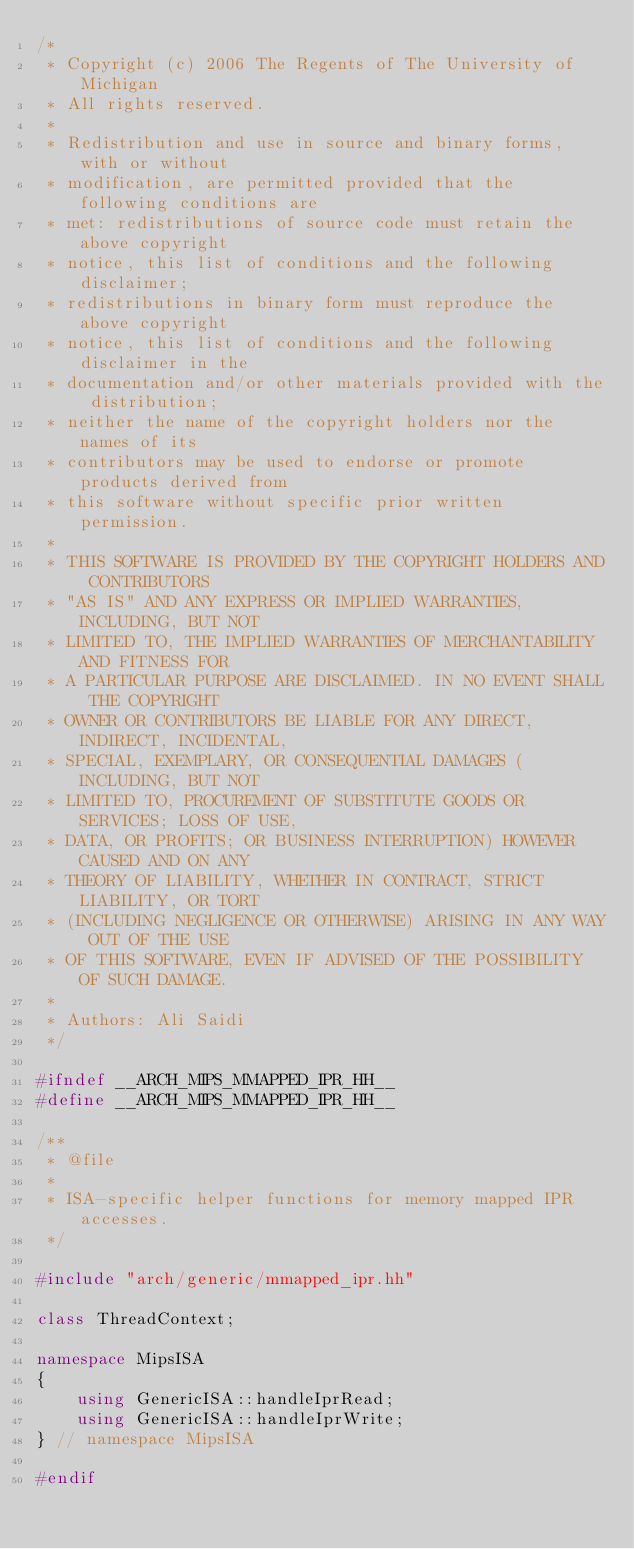<code> <loc_0><loc_0><loc_500><loc_500><_C++_>/*
 * Copyright (c) 2006 The Regents of The University of Michigan
 * All rights reserved.
 *
 * Redistribution and use in source and binary forms, with or without
 * modification, are permitted provided that the following conditions are
 * met: redistributions of source code must retain the above copyright
 * notice, this list of conditions and the following disclaimer;
 * redistributions in binary form must reproduce the above copyright
 * notice, this list of conditions and the following disclaimer in the
 * documentation and/or other materials provided with the distribution;
 * neither the name of the copyright holders nor the names of its
 * contributors may be used to endorse or promote products derived from
 * this software without specific prior written permission.
 *
 * THIS SOFTWARE IS PROVIDED BY THE COPYRIGHT HOLDERS AND CONTRIBUTORS
 * "AS IS" AND ANY EXPRESS OR IMPLIED WARRANTIES, INCLUDING, BUT NOT
 * LIMITED TO, THE IMPLIED WARRANTIES OF MERCHANTABILITY AND FITNESS FOR
 * A PARTICULAR PURPOSE ARE DISCLAIMED. IN NO EVENT SHALL THE COPYRIGHT
 * OWNER OR CONTRIBUTORS BE LIABLE FOR ANY DIRECT, INDIRECT, INCIDENTAL,
 * SPECIAL, EXEMPLARY, OR CONSEQUENTIAL DAMAGES (INCLUDING, BUT NOT
 * LIMITED TO, PROCUREMENT OF SUBSTITUTE GOODS OR SERVICES; LOSS OF USE,
 * DATA, OR PROFITS; OR BUSINESS INTERRUPTION) HOWEVER CAUSED AND ON ANY
 * THEORY OF LIABILITY, WHETHER IN CONTRACT, STRICT LIABILITY, OR TORT
 * (INCLUDING NEGLIGENCE OR OTHERWISE) ARISING IN ANY WAY OUT OF THE USE
 * OF THIS SOFTWARE, EVEN IF ADVISED OF THE POSSIBILITY OF SUCH DAMAGE.
 *
 * Authors: Ali Saidi
 */

#ifndef __ARCH_MIPS_MMAPPED_IPR_HH__
#define __ARCH_MIPS_MMAPPED_IPR_HH__

/**
 * @file
 *
 * ISA-specific helper functions for memory mapped IPR accesses.
 */

#include "arch/generic/mmapped_ipr.hh"

class ThreadContext;

namespace MipsISA
{
    using GenericISA::handleIprRead;
    using GenericISA::handleIprWrite;
} // namespace MipsISA

#endif
</code> 